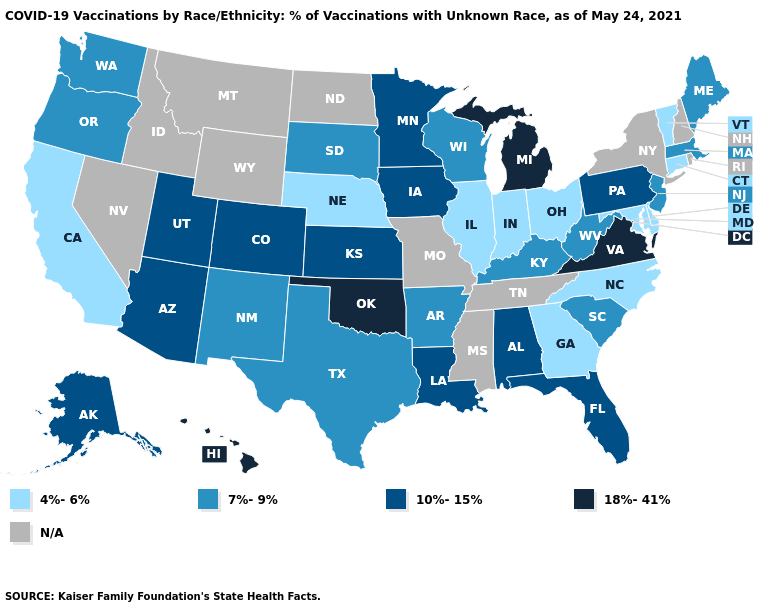What is the value of Michigan?
Answer briefly. 18%-41%. Name the states that have a value in the range 10%-15%?
Write a very short answer. Alabama, Alaska, Arizona, Colorado, Florida, Iowa, Kansas, Louisiana, Minnesota, Pennsylvania, Utah. What is the value of Nevada?
Short answer required. N/A. How many symbols are there in the legend?
Keep it brief. 5. Among the states that border Virginia , does West Virginia have the lowest value?
Be succinct. No. Does Oregon have the lowest value in the USA?
Keep it brief. No. What is the value of Illinois?
Short answer required. 4%-6%. What is the lowest value in the MidWest?
Answer briefly. 4%-6%. What is the lowest value in the USA?
Concise answer only. 4%-6%. Name the states that have a value in the range 18%-41%?
Quick response, please. Hawaii, Michigan, Oklahoma, Virginia. Name the states that have a value in the range 18%-41%?
Short answer required. Hawaii, Michigan, Oklahoma, Virginia. How many symbols are there in the legend?
Answer briefly. 5. What is the value of Alaska?
Keep it brief. 10%-15%. 